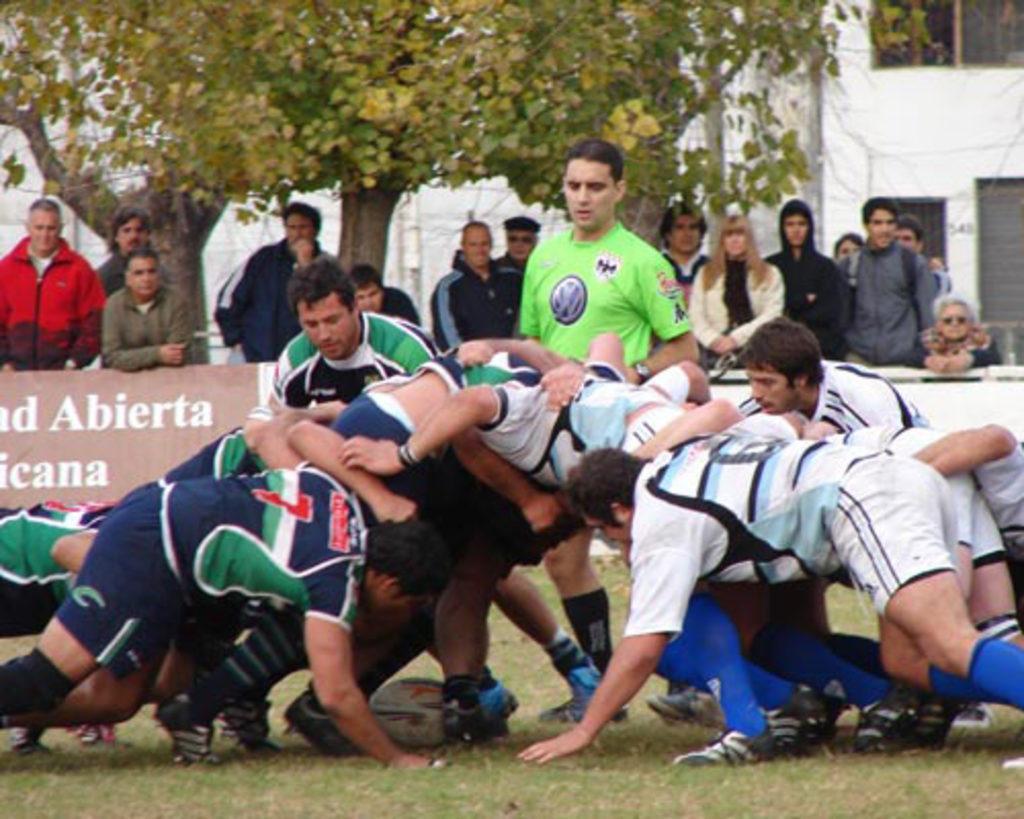How would you summarize this image in a sentence or two? This image consists of many people playing american football. At the bottom, there is green grass. In the background, there is a building along with a tree. 